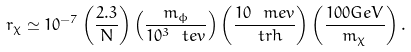<formula> <loc_0><loc_0><loc_500><loc_500>r _ { \chi } \simeq 1 0 ^ { - 7 } \left ( \frac { 2 . 3 } { N } \right ) \left ( \frac { m _ { \phi } } { 1 0 ^ { 3 } \ t e v } \right ) \left ( \frac { 1 0 \ m e v } { \ t r h } \right ) \left ( \frac { 1 0 0 G e V } { m _ { \chi } } \right ) .</formula> 